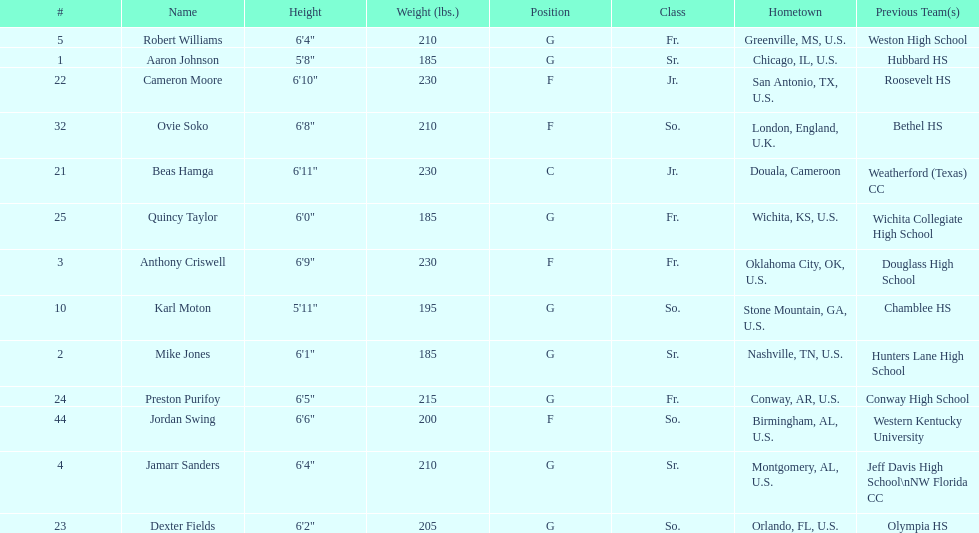What is the count of juniors present in the team? 2. 